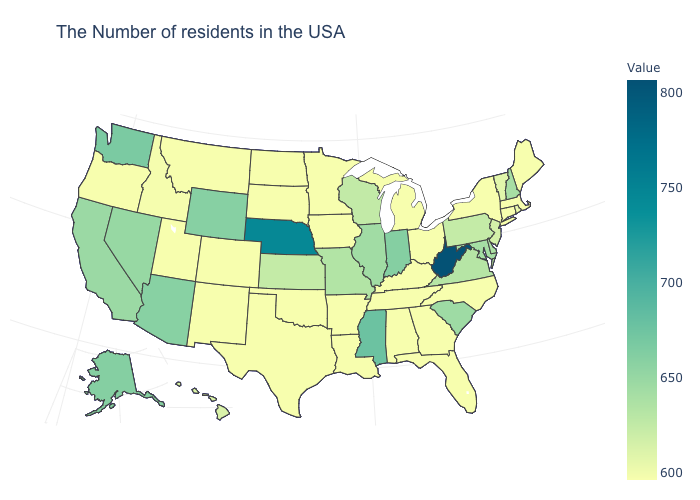Among the states that border New York , which have the lowest value?
Answer briefly. Massachusetts, Connecticut. Is the legend a continuous bar?
Be succinct. Yes. Among the states that border Georgia , does South Carolina have the lowest value?
Give a very brief answer. No. Does Massachusetts have the lowest value in the Northeast?
Write a very short answer. Yes. Among the states that border South Carolina , which have the lowest value?
Short answer required. North Carolina, Georgia. Is the legend a continuous bar?
Write a very short answer. Yes. Which states hav the highest value in the MidWest?
Be succinct. Nebraska. 